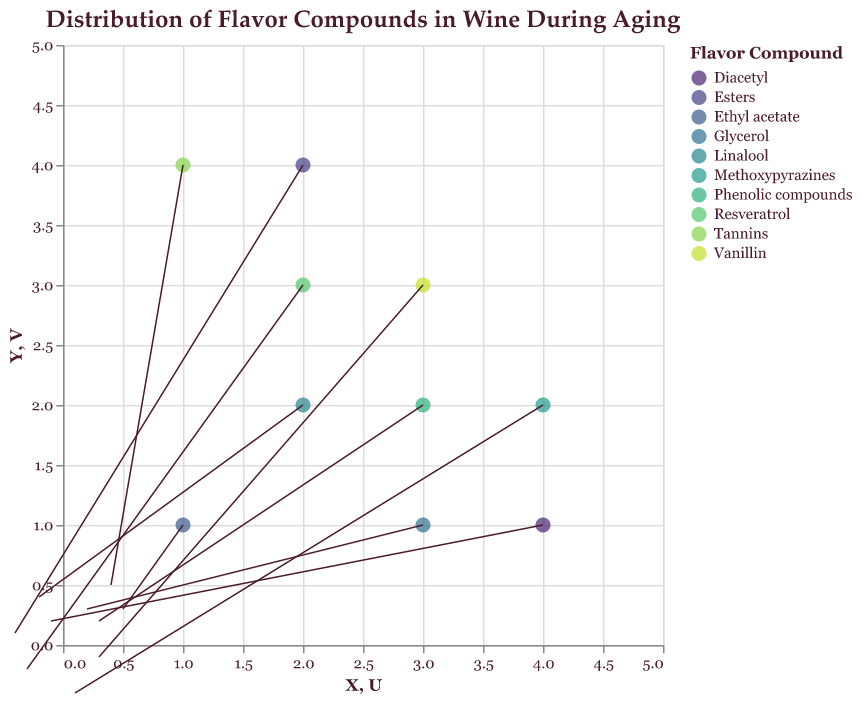What is the title of the plot? The title is displayed at the top of the plot. It describes the main topic of the plot, which is "Distribution of Flavor Compounds in Wine During Aging".
Answer: Distribution of Flavor Compounds in Wine During Aging How many flavor compounds are represented in the plot? The legend to the right indicates each distinct color represents a different flavor compound. Count the unique entries in the legend.
Answer: 10 Which compound is located at the coordinates (1, 1)? Find the data point positioned at (1,1) on the x and y axes and check its corresponding tooltip or label.
Answer: Ethyl acetate What is the direction of the arrow for Tannins? Locate the arrow starting at the point for Tannins and observe the direction in which it is pointing by following the rule marks from start to end.
Answer: Diagonally up and to the right Which compound has the largest vector magnitude? Calculate the magnitude for each vector using the formula √(U^2 + V^2) and compare them. Tannins has a vector with U=0.4 and V=0.5, which approximates to a magnitude of 0.64.
Answer: Tannins Which compound is decreasing in the y-axis but increasing in the x-axis direction? Check the direction of the arrows: if U > 0 (increasing in x) and V < 0 (decreasing in y), then find out which compound matches this description.
Answer: Vanillin What are the coordinates of the Glycerol compound? Locate the data point or arrow labeled as Glycerol and read off the x and y coordinates shown.
Answer: (3, 1) Between Linalool and Resveratrol, which compound has a higher change in the y-direction? Compare the V values for Linalool (0.4) and Resveratrol (-0.2). The compound with a higher positive V value has a higher change in the y-direction.
Answer: Linalool Which compounds have vectors that point leftwards? Identify the compounds where the U value is negative, which indicates a leftward direction of the arrow. Diacetyl, Resveratrol, Linalool, Esters.
Answer: Diacetyl, Resveratrol, Linalool, Esters Which data point has the smallest magnitude in its vector? Evaluate the magnitude of each vector using the formula √(U^2+V^2) and compare them; Methoxypyrazines has values (U=0.1, V=-0.4) which approximates to 0.41.
Answer: Methoxypyrazines 